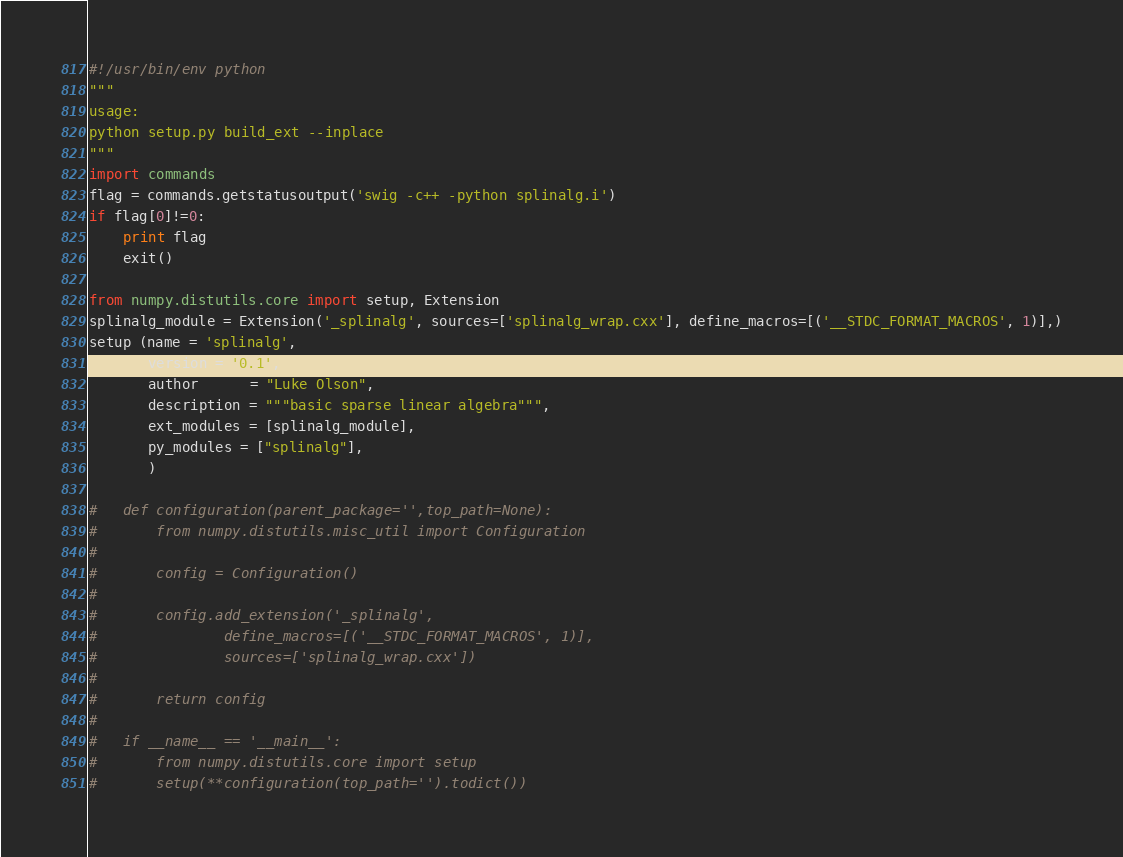Convert code to text. <code><loc_0><loc_0><loc_500><loc_500><_Python_>#!/usr/bin/env python
"""
usage:
python setup.py build_ext --inplace
"""
import commands
flag = commands.getstatusoutput('swig -c++ -python splinalg.i')
if flag[0]!=0:
    print flag
    exit()

from numpy.distutils.core import setup, Extension
splinalg_module = Extension('_splinalg', sources=['splinalg_wrap.cxx'], define_macros=[('__STDC_FORMAT_MACROS', 1)],)
setup (name = 'splinalg',
       version = '0.1',
       author      = "Luke Olson",
       description = """basic sparse linear algebra""",
       ext_modules = [splinalg_module],
       py_modules = ["splinalg"],
       )

#   def configuration(parent_package='',top_path=None):
#       from numpy.distutils.misc_util import Configuration
#   
#       config = Configuration()
#   
#       config.add_extension('_splinalg',
#               define_macros=[('__STDC_FORMAT_MACROS', 1)],
#               sources=['splinalg_wrap.cxx'])
#   
#       return config
#   
#   if __name__ == '__main__':
#       from numpy.distutils.core import setup
#       setup(**configuration(top_path='').todict())
</code> 